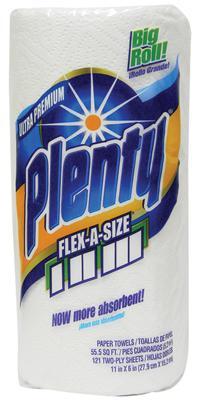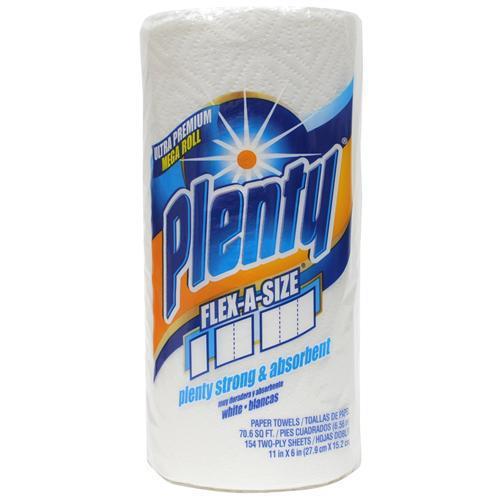The first image is the image on the left, the second image is the image on the right. Analyze the images presented: Is the assertion "One image shows at least one six-roll multipack of paper towels." valid? Answer yes or no. No. The first image is the image on the left, the second image is the image on the right. Given the left and right images, does the statement "There is exactly one paper towel roll in the left image" hold true? Answer yes or no. Yes. 